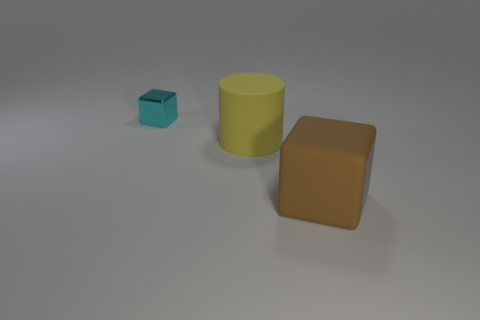There is another small thing that is the same shape as the brown thing; what material is it?
Your answer should be very brief. Metal. Is there anything else that is made of the same material as the tiny object?
Ensure brevity in your answer.  No. What number of other things are the same shape as the small cyan thing?
Provide a succinct answer. 1. There is a large matte thing behind the thing to the right of the cylinder; what number of small cyan shiny things are left of it?
Provide a short and direct response. 1. What number of other large yellow matte things have the same shape as the yellow matte thing?
Keep it short and to the point. 0. There is a tiny object that is left of the big rubber thing that is behind the object in front of the yellow cylinder; what shape is it?
Your answer should be compact. Cube. There is a yellow rubber cylinder; is it the same size as the cube in front of the big yellow rubber cylinder?
Make the answer very short. Yes. Are there any yellow matte objects of the same size as the metal object?
Provide a short and direct response. No. How many other things are made of the same material as the cylinder?
Your answer should be compact. 1. There is a object that is both to the left of the brown thing and in front of the small cube; what is its color?
Offer a very short reply. Yellow. 